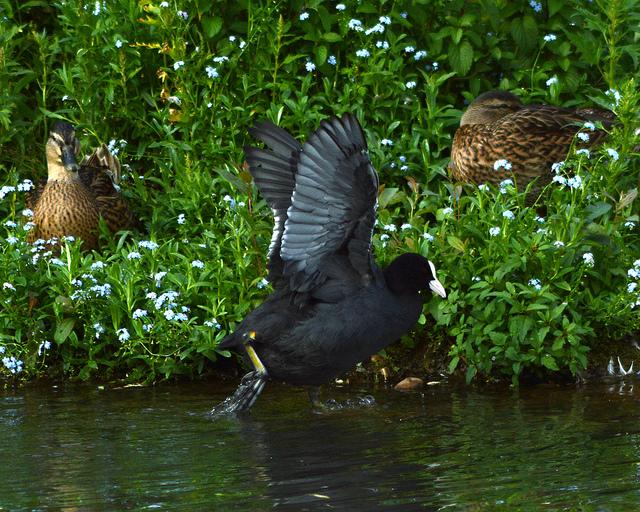What is the duck in the water doing?
Concise answer only. Flying. Where is the duck?
Short answer required. Water. How many brown ducks can you see?
Quick response, please. 2. What kind of animals are laying down?
Give a very brief answer. Ducks. 